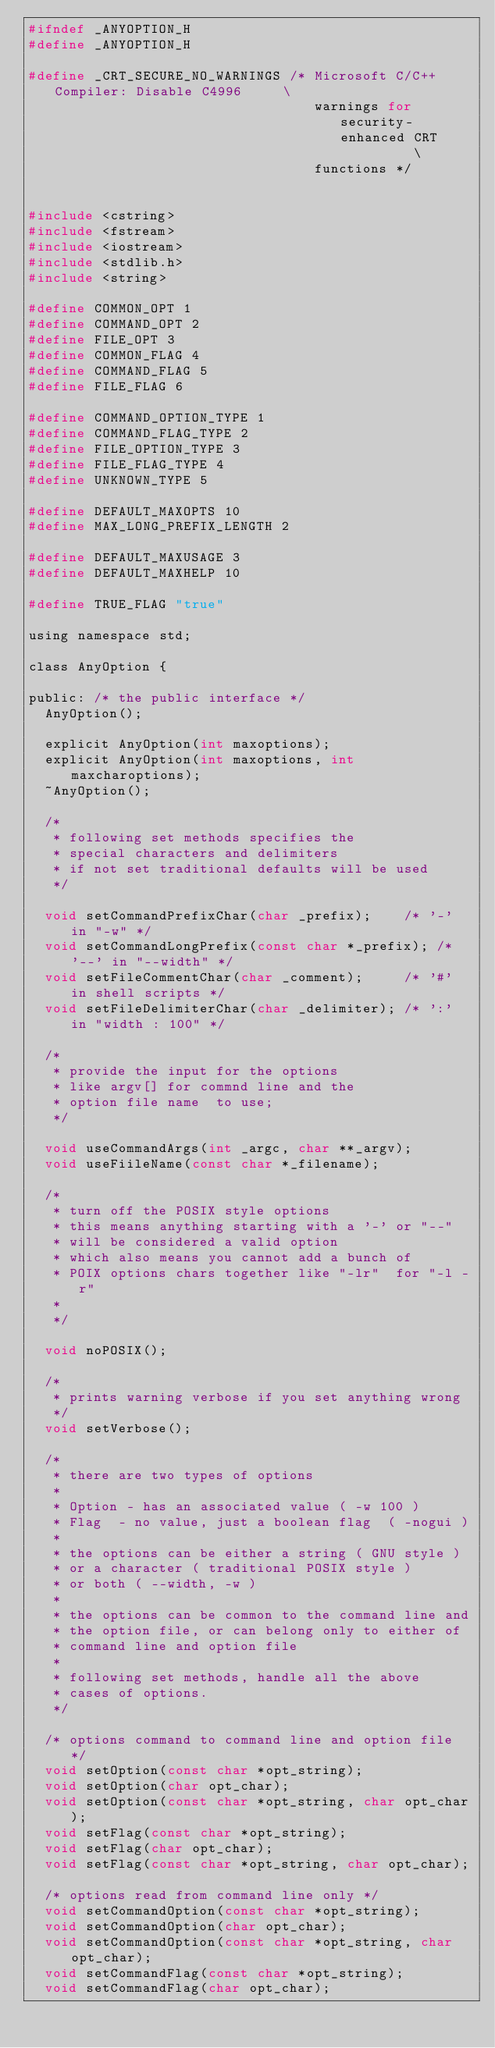<code> <loc_0><loc_0><loc_500><loc_500><_C_>#ifndef _ANYOPTION_H
#define _ANYOPTION_H

#define _CRT_SECURE_NO_WARNINGS /* Microsoft C/C++ Compiler: Disable C4996     \
                                   warnings for security-enhanced CRT          \
                                   functions */


#include <cstring>
#include <fstream>
#include <iostream>
#include <stdlib.h>
#include <string>

#define COMMON_OPT 1
#define COMMAND_OPT 2
#define FILE_OPT 3
#define COMMON_FLAG 4
#define COMMAND_FLAG 5
#define FILE_FLAG 6

#define COMMAND_OPTION_TYPE 1
#define COMMAND_FLAG_TYPE 2
#define FILE_OPTION_TYPE 3
#define FILE_FLAG_TYPE 4
#define UNKNOWN_TYPE 5

#define DEFAULT_MAXOPTS 10
#define MAX_LONG_PREFIX_LENGTH 2

#define DEFAULT_MAXUSAGE 3
#define DEFAULT_MAXHELP 10

#define TRUE_FLAG "true"

using namespace std;

class AnyOption {

public: /* the public interface */
  AnyOption();

  explicit AnyOption(int maxoptions);
  explicit AnyOption(int maxoptions, int maxcharoptions);
  ~AnyOption();

  /*
   * following set methods specifies the
   * special characters and delimiters
   * if not set traditional defaults will be used
   */

  void setCommandPrefixChar(char _prefix);    /* '-' in "-w" */
  void setCommandLongPrefix(const char *_prefix); /* '--' in "--width" */
  void setFileCommentChar(char _comment);     /* '#' in shell scripts */
  void setFileDelimiterChar(char _delimiter); /* ':' in "width : 100" */

  /*
   * provide the input for the options
   * like argv[] for commnd line and the
   * option file name  to use;
   */

  void useCommandArgs(int _argc, char **_argv);
  void useFiileName(const char *_filename);

  /*
   * turn off the POSIX style options
   * this means anything starting with a '-' or "--"
   * will be considered a valid option
   * which also means you cannot add a bunch of
   * POIX options chars together like "-lr"  for "-l -r"
   *
   */

  void noPOSIX();

  /*
   * prints warning verbose if you set anything wrong
   */
  void setVerbose();

  /*
   * there are two types of options
   *
   * Option - has an associated value ( -w 100 )
   * Flag  - no value, just a boolean flag  ( -nogui )
   *
   * the options can be either a string ( GNU style )
   * or a character ( traditional POSIX style )
   * or both ( --width, -w )
   *
   * the options can be common to the command line and
   * the option file, or can belong only to either of
   * command line and option file
   *
   * following set methods, handle all the above
   * cases of options.
   */

  /* options command to command line and option file */
  void setOption(const char *opt_string);
  void setOption(char opt_char);
  void setOption(const char *opt_string, char opt_char);
  void setFlag(const char *opt_string);
  void setFlag(char opt_char);
  void setFlag(const char *opt_string, char opt_char);

  /* options read from command line only */
  void setCommandOption(const char *opt_string);
  void setCommandOption(char opt_char);
  void setCommandOption(const char *opt_string, char opt_char);
  void setCommandFlag(const char *opt_string);
  void setCommandFlag(char opt_char);</code> 